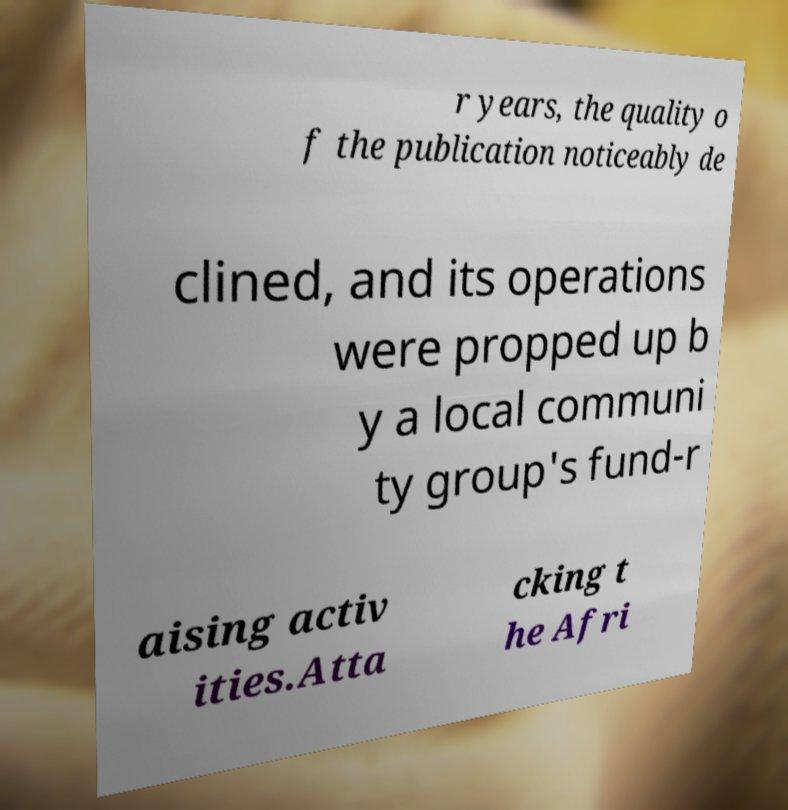There's text embedded in this image that I need extracted. Can you transcribe it verbatim? r years, the quality o f the publication noticeably de clined, and its operations were propped up b y a local communi ty group's fund-r aising activ ities.Atta cking t he Afri 